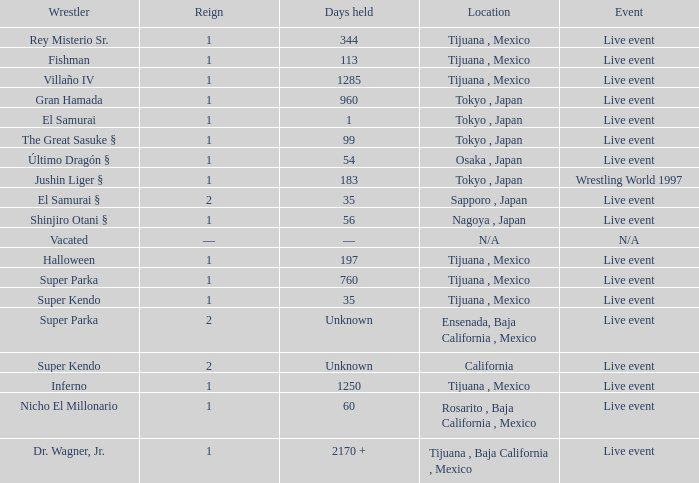What type of event had the wrestler with a reign of 2 and held the title for 35 days? Live event. 